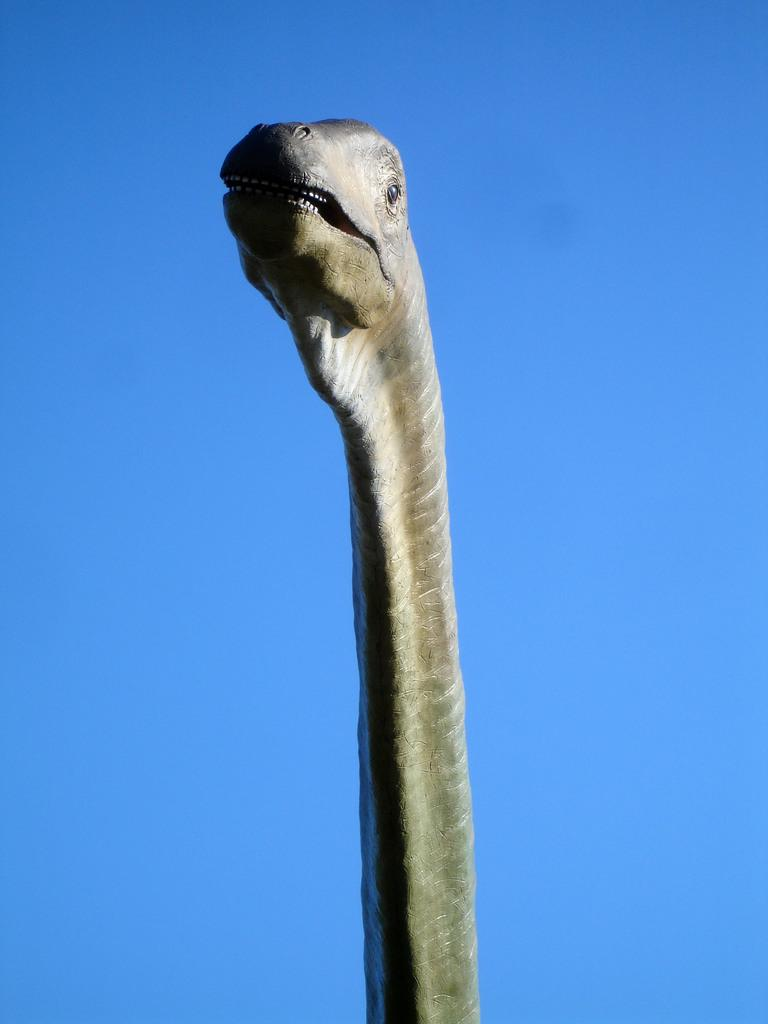What type of object is featured in the image? There is an animal head in the image. What can be seen in the background of the image? The sky is visible in the image. What type of brush is used to create the animal's face in the image? There is no brush or painting process mentioned in the image; it simply features an animal head. Can you tell me how many faces are visible in the image? There is only one face visible in the image, which is the animal's face. 